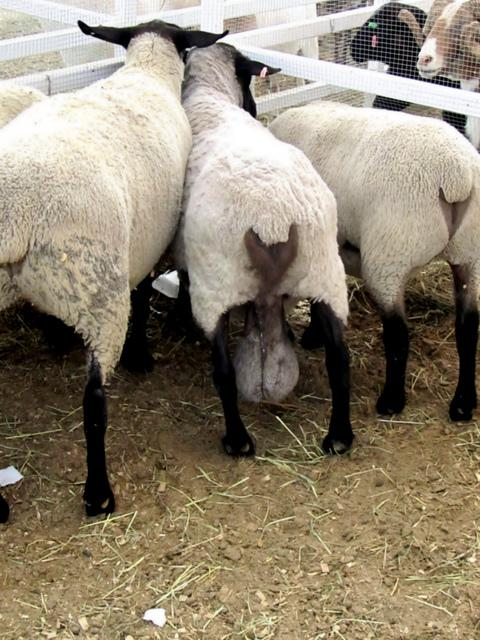What is hanging on the belly of the sheep in the middle? Please explain your reasoning. udder. The female has a milk-filled mammary gland. 